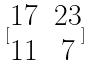<formula> <loc_0><loc_0><loc_500><loc_500>[ \begin{matrix} 1 7 & 2 3 \\ 1 1 & 7 \end{matrix} ]</formula> 